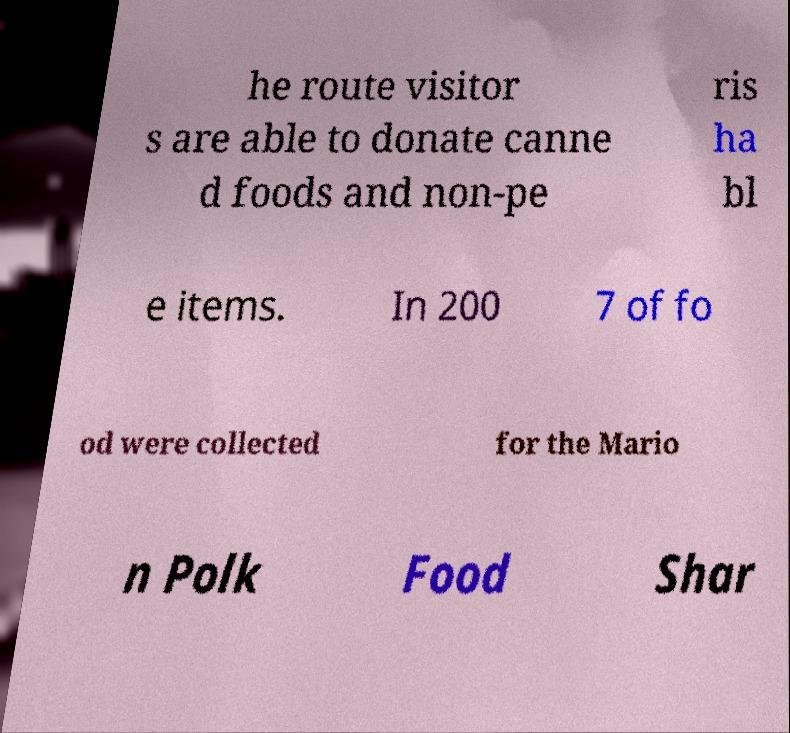Can you read and provide the text displayed in the image?This photo seems to have some interesting text. Can you extract and type it out for me? he route visitor s are able to donate canne d foods and non-pe ris ha bl e items. In 200 7 of fo od were collected for the Mario n Polk Food Shar 